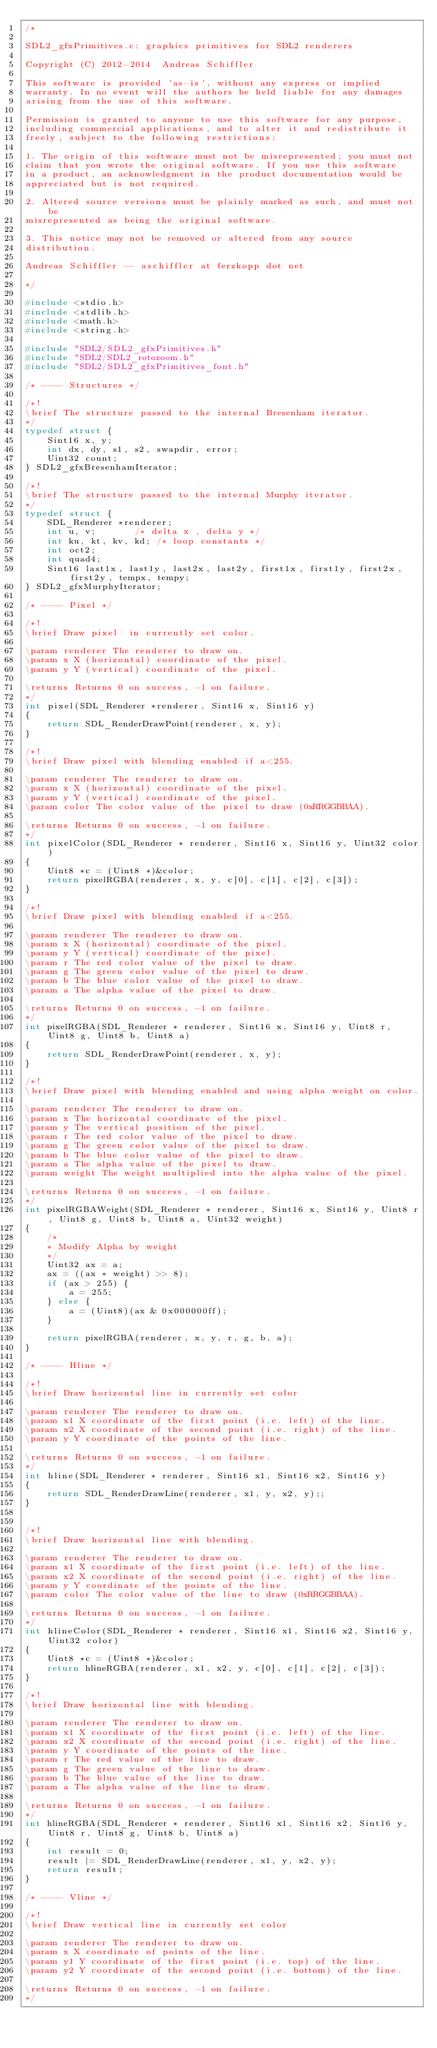<code> <loc_0><loc_0><loc_500><loc_500><_C_>/* 

SDL2_gfxPrimitives.c: graphics primitives for SDL2 renderers

Copyright (C) 2012-2014  Andreas Schiffler

This software is provided 'as-is', without any express or implied
warranty. In no event will the authors be held liable for any damages
arising from the use of this software.

Permission is granted to anyone to use this software for any purpose,
including commercial applications, and to alter it and redistribute it
freely, subject to the following restrictions:

1. The origin of this software must not be misrepresented; you must not
claim that you wrote the original software. If you use this software
in a product, an acknowledgment in the product documentation would be
appreciated but is not required.

2. Altered source versions must be plainly marked as such, and must not be
misrepresented as being the original software.

3. This notice may not be removed or altered from any source
distribution.

Andreas Schiffler -- aschiffler at ferzkopp dot net

*/

#include <stdio.h>
#include <stdlib.h>
#include <math.h>
#include <string.h>

#include "SDL2/SDL2_gfxPrimitives.h"
#include "SDL2/SDL2_rotozoom.h"
#include "SDL2/SDL2_gfxPrimitives_font.h"

/* ---- Structures */

/*!
\brief The structure passed to the internal Bresenham iterator.
*/
typedef struct {
	Sint16 x, y;
	int dx, dy, s1, s2, swapdir, error;
	Uint32 count;
} SDL2_gfxBresenhamIterator;

/*!
\brief The structure passed to the internal Murphy iterator.
*/
typedef struct {
	SDL_Renderer *renderer;
	int u, v;		/* delta x , delta y */
	int ku, kt, kv, kd;	/* loop constants */
	int oct2;
	int quad4;
	Sint16 last1x, last1y, last2x, last2y, first1x, first1y, first2x, first2y, tempx, tempy;
} SDL2_gfxMurphyIterator;

/* ---- Pixel */

/*!
\brief Draw pixel  in currently set color.

\param renderer The renderer to draw on.
\param x X (horizontal) coordinate of the pixel.
\param y Y (vertical) coordinate of the pixel.

\returns Returns 0 on success, -1 on failure.
*/
int pixel(SDL_Renderer *renderer, Sint16 x, Sint16 y)
{
	return SDL_RenderDrawPoint(renderer, x, y);
}

/*!
\brief Draw pixel with blending enabled if a<255.

\param renderer The renderer to draw on.
\param x X (horizontal) coordinate of the pixel.
\param y Y (vertical) coordinate of the pixel.
\param color The color value of the pixel to draw (0xRRGGBBAA). 

\returns Returns 0 on success, -1 on failure.
*/
int pixelColor(SDL_Renderer * renderer, Sint16 x, Sint16 y, Uint32 color)
{
	Uint8 *c = (Uint8 *)&color; 
	return pixelRGBA(renderer, x, y, c[0], c[1], c[2], c[3]);
}

/*!
\brief Draw pixel with blending enabled if a<255.

\param renderer The renderer to draw on.
\param x X (horizontal) coordinate of the pixel.
\param y Y (vertical) coordinate of the pixel.
\param r The red color value of the pixel to draw. 
\param g The green color value of the pixel to draw.
\param b The blue color value of the pixel to draw.
\param a The alpha value of the pixel to draw.

\returns Returns 0 on success, -1 on failure.
*/
int pixelRGBA(SDL_Renderer * renderer, Sint16 x, Sint16 y, Uint8 r, Uint8 g, Uint8 b, Uint8 a)
{
	return SDL_RenderDrawPoint(renderer, x, y);
}

/*!
\brief Draw pixel with blending enabled and using alpha weight on color.

\param renderer The renderer to draw on.
\param x The horizontal coordinate of the pixel.
\param y The vertical position of the pixel.
\param r The red color value of the pixel to draw. 
\param g The green color value of the pixel to draw.
\param b The blue color value of the pixel to draw.
\param a The alpha value of the pixel to draw.
\param weight The weight multiplied into the alpha value of the pixel.

\returns Returns 0 on success, -1 on failure.
*/
int pixelRGBAWeight(SDL_Renderer * renderer, Sint16 x, Sint16 y, Uint8 r, Uint8 g, Uint8 b, Uint8 a, Uint32 weight)
{
	/*
	* Modify Alpha by weight 
	*/
	Uint32 ax = a;
	ax = ((ax * weight) >> 8);
	if (ax > 255) {
		a = 255;
	} else {
		a = (Uint8)(ax & 0x000000ff);
	}

	return pixelRGBA(renderer, x, y, r, g, b, a);
}

/* ---- Hline */

/*!
\brief Draw horizontal line in currently set color

\param renderer The renderer to draw on.
\param x1 X coordinate of the first point (i.e. left) of the line.
\param x2 X coordinate of the second point (i.e. right) of the line.
\param y Y coordinate of the points of the line.

\returns Returns 0 on success, -1 on failure.
*/
int hline(SDL_Renderer * renderer, Sint16 x1, Sint16 x2, Sint16 y)
{
	return SDL_RenderDrawLine(renderer, x1, y, x2, y);;
}


/*!
\brief Draw horizontal line with blending.

\param renderer The renderer to draw on.
\param x1 X coordinate of the first point (i.e. left) of the line.
\param x2 X coordinate of the second point (i.e. right) of the line.
\param y Y coordinate of the points of the line.
\param color The color value of the line to draw (0xRRGGBBAA). 

\returns Returns 0 on success, -1 on failure.
*/
int hlineColor(SDL_Renderer * renderer, Sint16 x1, Sint16 x2, Sint16 y, Uint32 color)
{
	Uint8 *c = (Uint8 *)&color; 
	return hlineRGBA(renderer, x1, x2, y, c[0], c[1], c[2], c[3]);
}

/*!
\brief Draw horizontal line with blending.

\param renderer The renderer to draw on.
\param x1 X coordinate of the first point (i.e. left) of the line.
\param x2 X coordinate of the second point (i.e. right) of the line.
\param y Y coordinate of the points of the line.
\param r The red value of the line to draw. 
\param g The green value of the line to draw. 
\param b The blue value of the line to draw. 
\param a The alpha value of the line to draw. 

\returns Returns 0 on success, -1 on failure.
*/
int hlineRGBA(SDL_Renderer * renderer, Sint16 x1, Sint16 x2, Sint16 y, Uint8 r, Uint8 g, Uint8 b, Uint8 a)
{
	int result = 0;
	result |= SDL_RenderDrawLine(renderer, x1, y, x2, y);
	return result;
}

/* ---- Vline */

/*!
\brief Draw vertical line in currently set color

\param renderer The renderer to draw on.
\param x X coordinate of points of the line.
\param y1 Y coordinate of the first point (i.e. top) of the line.
\param y2 Y coordinate of the second point (i.e. bottom) of the line.

\returns Returns 0 on success, -1 on failure.
*/</code> 